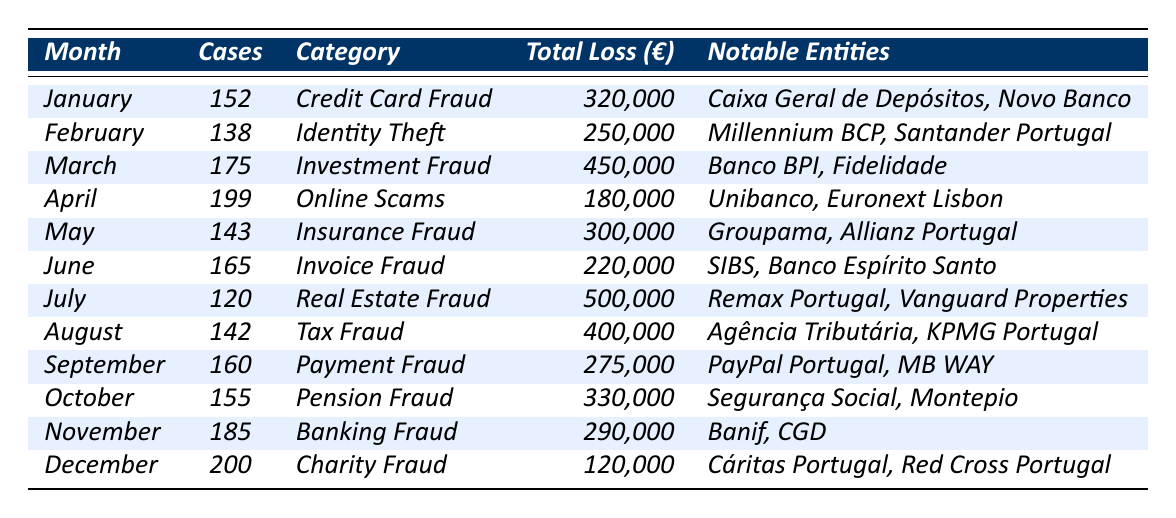What is the total number of financial fraud cases reported in December? The table states that in December, there were 200 cases reported.
Answer: 200 Which category of fraud had the highest total loss in May? The table indicates that in May, the Insurance Fraud category had a total loss of €300,000, which is the only entry for that month.
Answer: €300,000 How many fraud cases were reported in March compared to February? In March, there were 175 cases reported, whereas in February, there were 138 cases. The difference is 175 - 138 = 37.
Answer: 37 Which month recorded the least number of cases and what was the category? The month with the least number of cases was July with 120 reported cases, categorized as Real Estate Fraud.
Answer: July, Real Estate Fraud What is the average number of reported fraud cases per month across the year? First, you sum the reported cases: 152 + 138 + 175 + 199 + 143 + 165 + 120 + 142 + 160 + 155 + 185 + 200 = 1,810. Then, divide by the number of months (12): 1,810 / 12 = 150.83.
Answer: 150.83 Was there any month where the total loss exceeded €400,000? Checking the total loss for each month, only July with €500,000 and August with €400,000 meet this criterion, confirming that yes, there were months with losses above €400,000.
Answer: Yes What trend can be observed between the cases reported in November and December? In November, there were 185 cases reported and in December, there were 200 cases. This indicates an increase of 15 cases from November to December.
Answer: Increase of 15 cases Which entity is associated with the highest amount of financial loss in July? In July, the notable entity with the highest total loss of €500,000 is linked to Real Estate Fraud, which involves Remax Portugal and Vanguard Properties.
Answer: Remax Portugal, Vanguard Properties If we were to combine the total losses for both January and February, what would be the total? January's loss is €320,000 and February's loss is €250,000, so combine these: €320,000 + €250,000 = €570,000.
Answer: €570,000 In which month are the cases associated with Online Scams, and how do those cases compare to the month before? Online scams occurred in April with 199 cases, which is an increase of 34 cases compared to March, which had 175 cases.
Answer: April, increased by 34 cases 